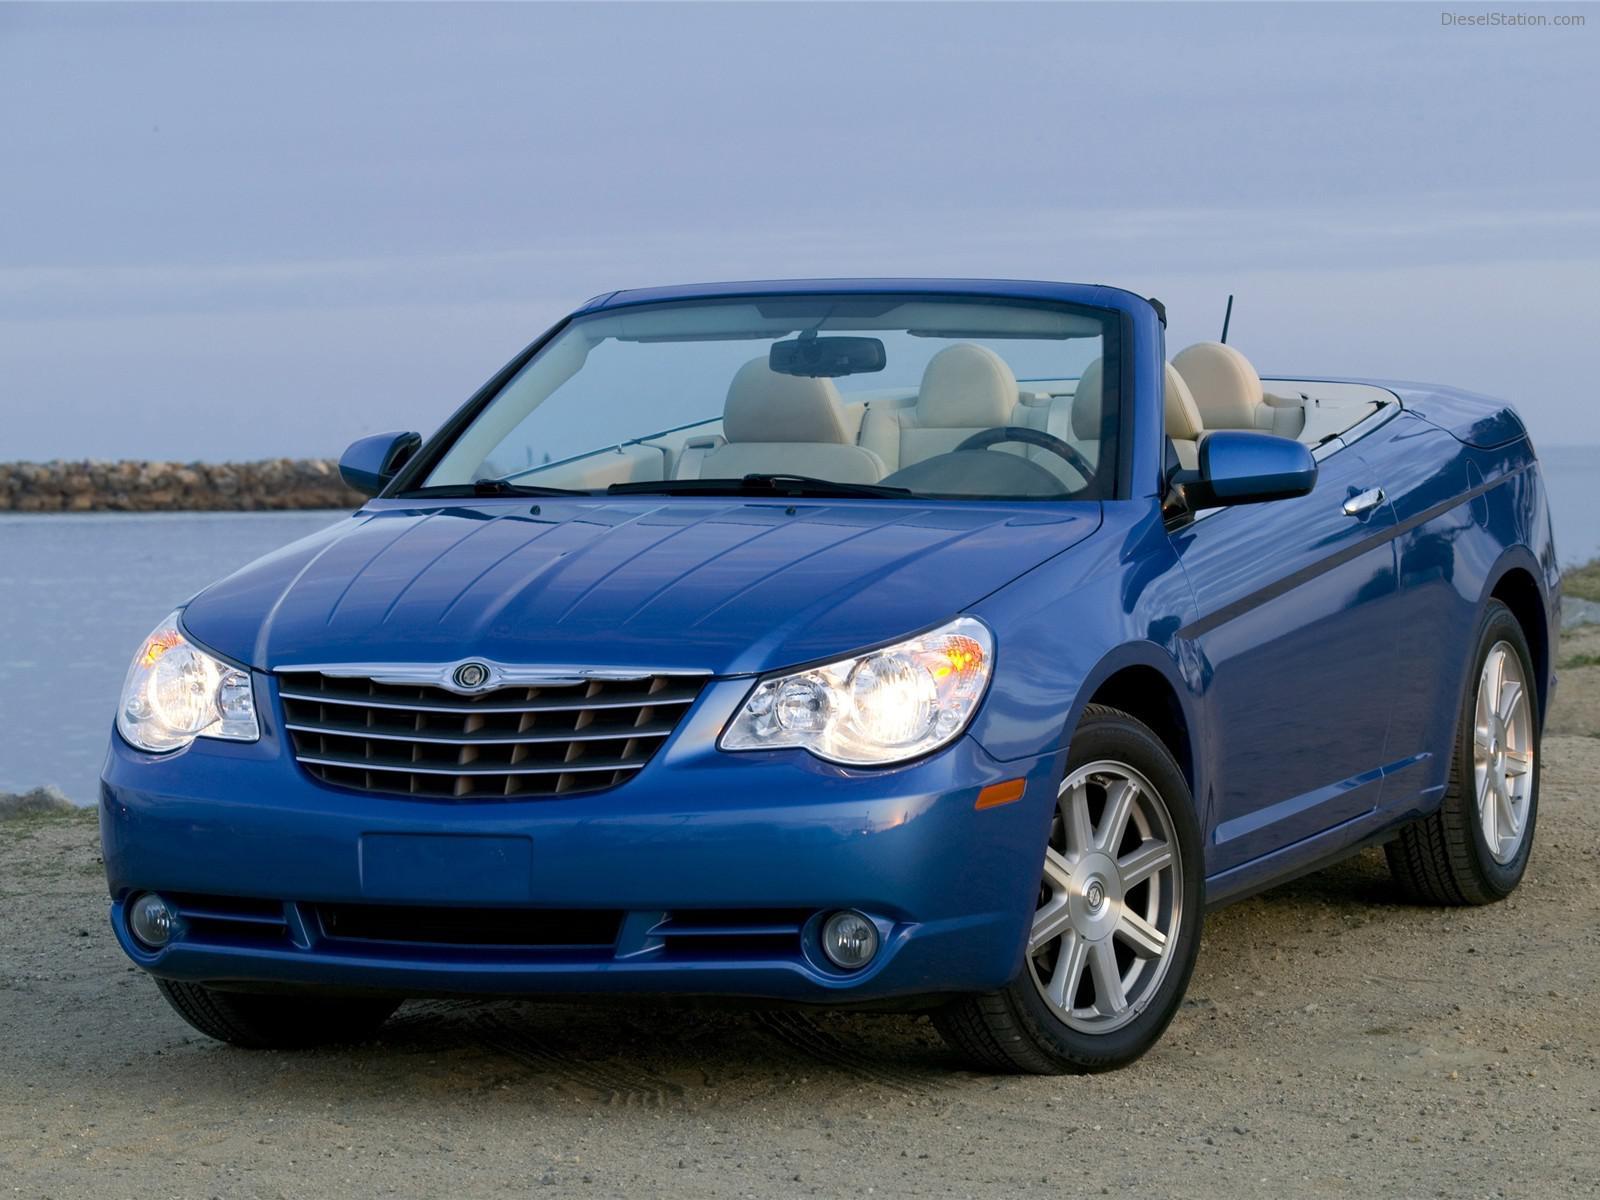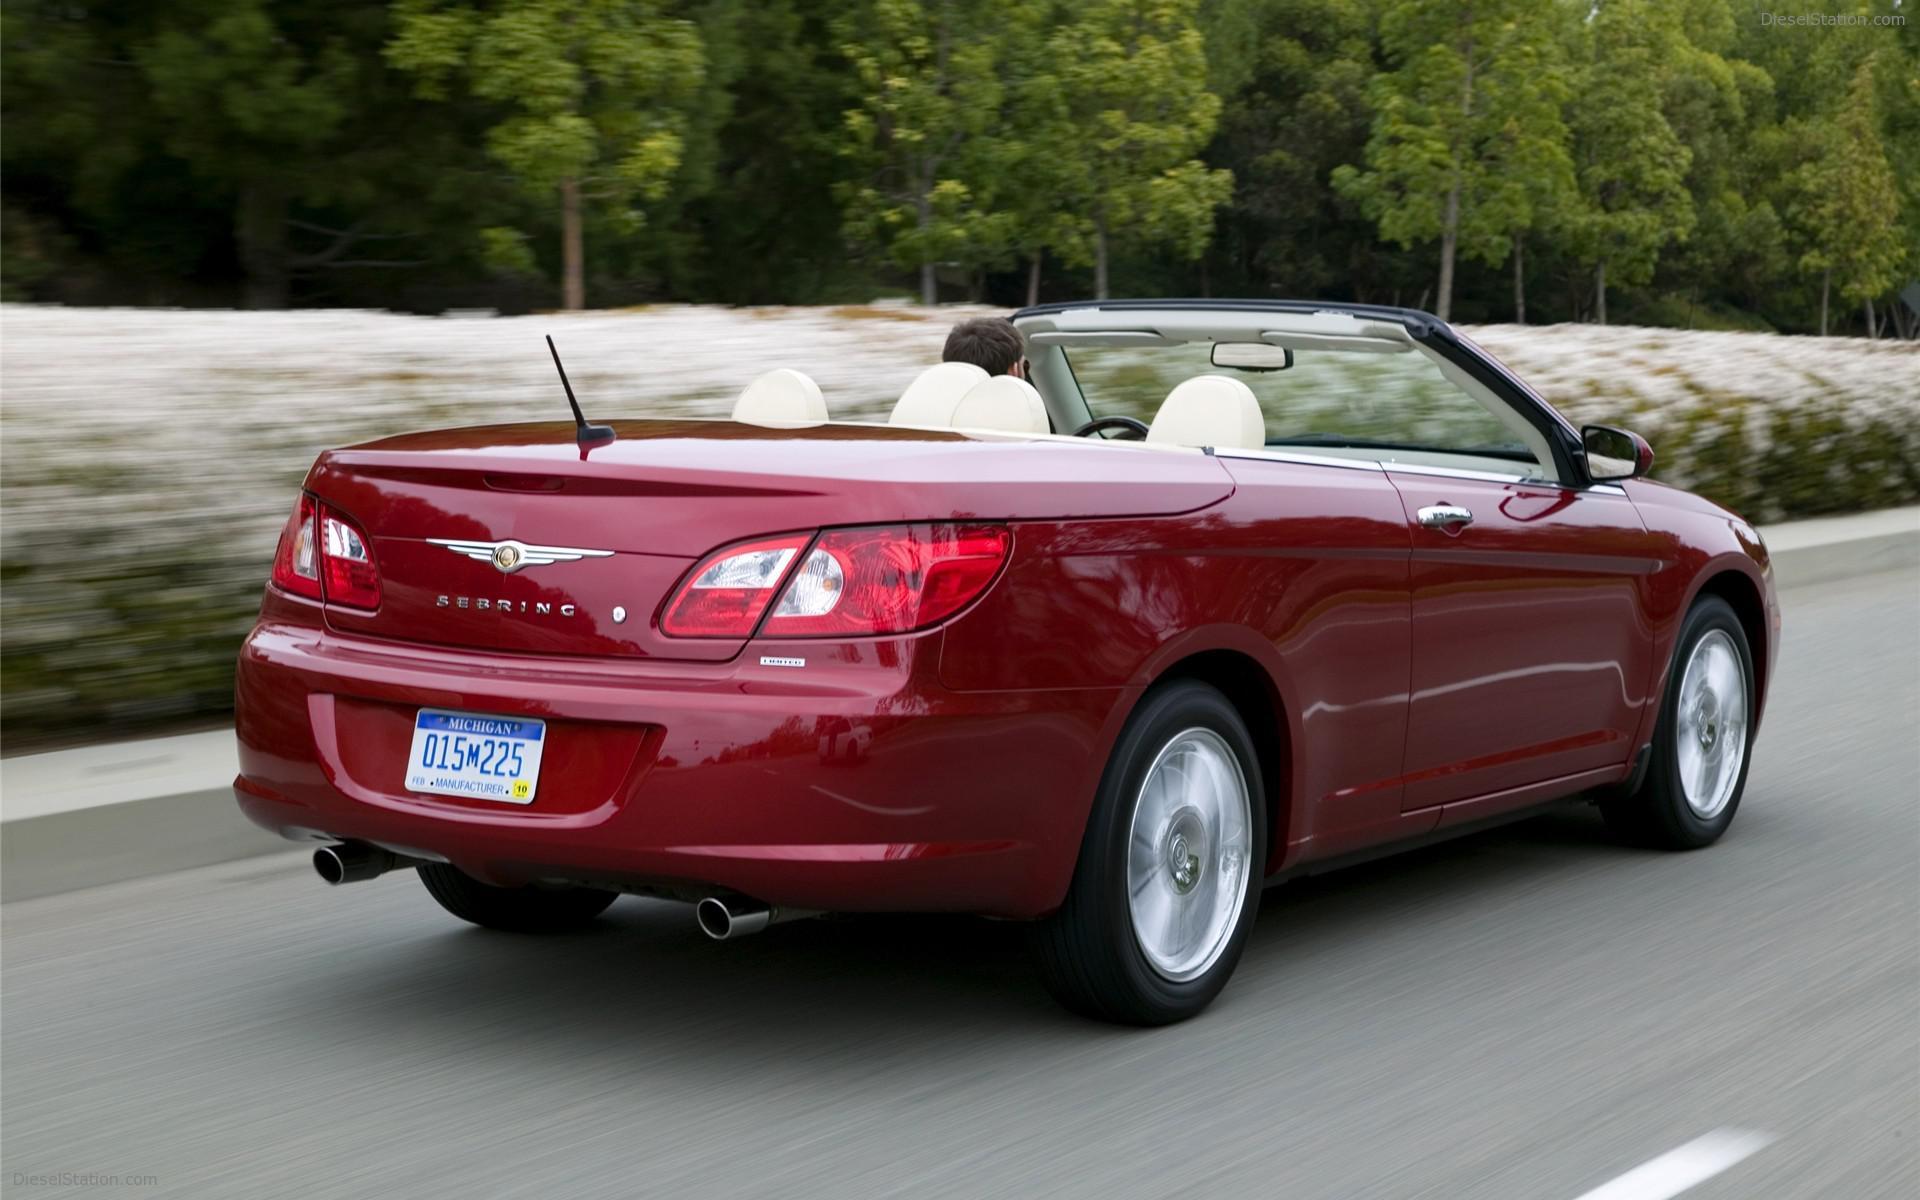The first image is the image on the left, the second image is the image on the right. Examine the images to the left and right. Is the description "Both images contain a red convertible automobile." accurate? Answer yes or no. No. 